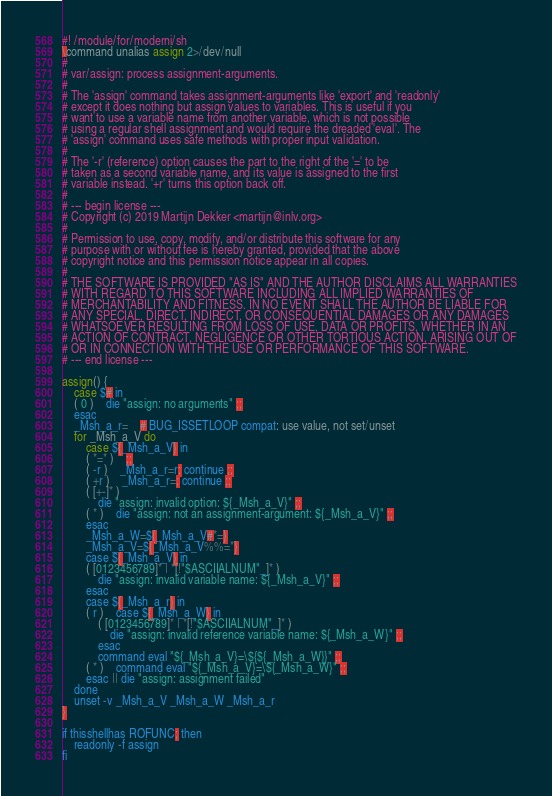Convert code to text. <code><loc_0><loc_0><loc_500><loc_500><_ObjectiveC_>#! /module/for/moderni/sh
\command unalias assign 2>/dev/null
#
# var/assign: process assignment-arguments.
#
# The 'assign' command takes assignment-arguments like 'export' and 'readonly'
# except it does nothing but assign values to variables. This is useful if you
# want to use a variable name from another variable, which is not possible
# using a regular shell assignment and would require the dreaded 'eval'. The
# 'assign' command uses safe methods with proper input validation.
#
# The '-r' (reference) option causes the part to the right of the '=' to be
# taken as a second variable name, and its value is assigned to the first
# variable instead. '+r' turns this option back off.
#
# --- begin license ---
# Copyright (c) 2019 Martijn Dekker <martijn@inlv.org>
#
# Permission to use, copy, modify, and/or distribute this software for any
# purpose with or without fee is hereby granted, provided that the above
# copyright notice and this permission notice appear in all copies.
#
# THE SOFTWARE IS PROVIDED "AS IS" AND THE AUTHOR DISCLAIMS ALL WARRANTIES
# WITH REGARD TO THIS SOFTWARE INCLUDING ALL IMPLIED WARRANTIES OF
# MERCHANTABILITY AND FITNESS. IN NO EVENT SHALL THE AUTHOR BE LIABLE FOR
# ANY SPECIAL, DIRECT, INDIRECT, OR CONSEQUENTIAL DAMAGES OR ANY DAMAGES
# WHATSOEVER RESULTING FROM LOSS OF USE, DATA OR PROFITS, WHETHER IN AN
# ACTION OF CONTRACT, NEGLIGENCE OR OTHER TORTIOUS ACTION, ARISING OUT OF
# OR IN CONNECTION WITH THE USE OR PERFORMANCE OF THIS SOFTWARE.
# --- end license ---

assign() {
	case $# in
	( 0 )	die "assign: no arguments" ;;
	esac
	_Msh_a_r=	# BUG_ISSETLOOP compat: use value, not set/unset
	for _Msh_a_V do
		case ${_Msh_a_V} in
		( *=* )	;;
		( -r )	_Msh_a_r=r; continue ;;
		( +r )	_Msh_a_r=; continue ;;
		( [+-]* )
			die "assign: invalid option: ${_Msh_a_V}" ;;
		( * )	die "assign: not an assignment-argument: ${_Msh_a_V}" ;;
		esac
		_Msh_a_W=${_Msh_a_V#*=}
		_Msh_a_V=${_Msh_a_V%%=*}
		case ${_Msh_a_V} in
		( [0123456789]* | *[!"$ASCIIALNUM"_]* )
			die "assign: invalid variable name: ${_Msh_a_V}" ;;
		esac
		case ${_Msh_a_r} in
		( r )	case ${_Msh_a_W} in
			( [0123456789]* | *[!"$ASCIIALNUM"_]* )
				die "assign: invalid reference variable name: ${_Msh_a_W}" ;;
			esac
			command eval "${_Msh_a_V}=\${${_Msh_a_W}}" ;;
		( * )	command eval "${_Msh_a_V}=\${_Msh_a_W}" ;;
		esac || die "assign: assignment failed"
	done
	unset -v _Msh_a_V _Msh_a_W _Msh_a_r
}

if thisshellhas ROFUNC; then
	readonly -f assign
fi
</code> 